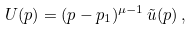Convert formula to latex. <formula><loc_0><loc_0><loc_500><loc_500>U ( p ) = ( p - p _ { 1 } ) ^ { \mu - 1 } \, \tilde { u } ( p ) \, ,</formula> 